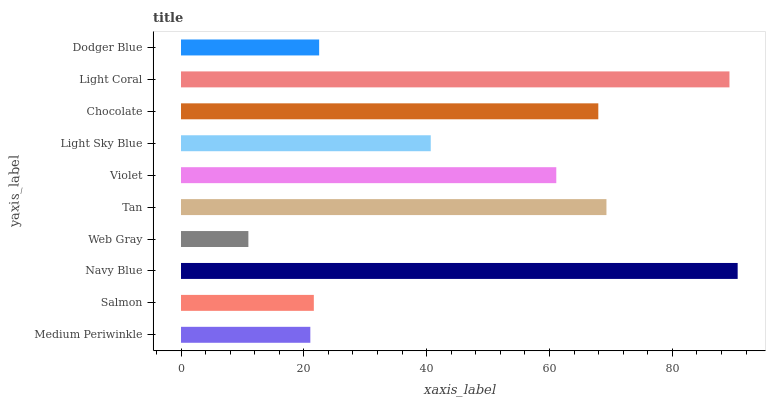Is Web Gray the minimum?
Answer yes or no. Yes. Is Navy Blue the maximum?
Answer yes or no. Yes. Is Salmon the minimum?
Answer yes or no. No. Is Salmon the maximum?
Answer yes or no. No. Is Salmon greater than Medium Periwinkle?
Answer yes or no. Yes. Is Medium Periwinkle less than Salmon?
Answer yes or no. Yes. Is Medium Periwinkle greater than Salmon?
Answer yes or no. No. Is Salmon less than Medium Periwinkle?
Answer yes or no. No. Is Violet the high median?
Answer yes or no. Yes. Is Light Sky Blue the low median?
Answer yes or no. Yes. Is Dodger Blue the high median?
Answer yes or no. No. Is Tan the low median?
Answer yes or no. No. 